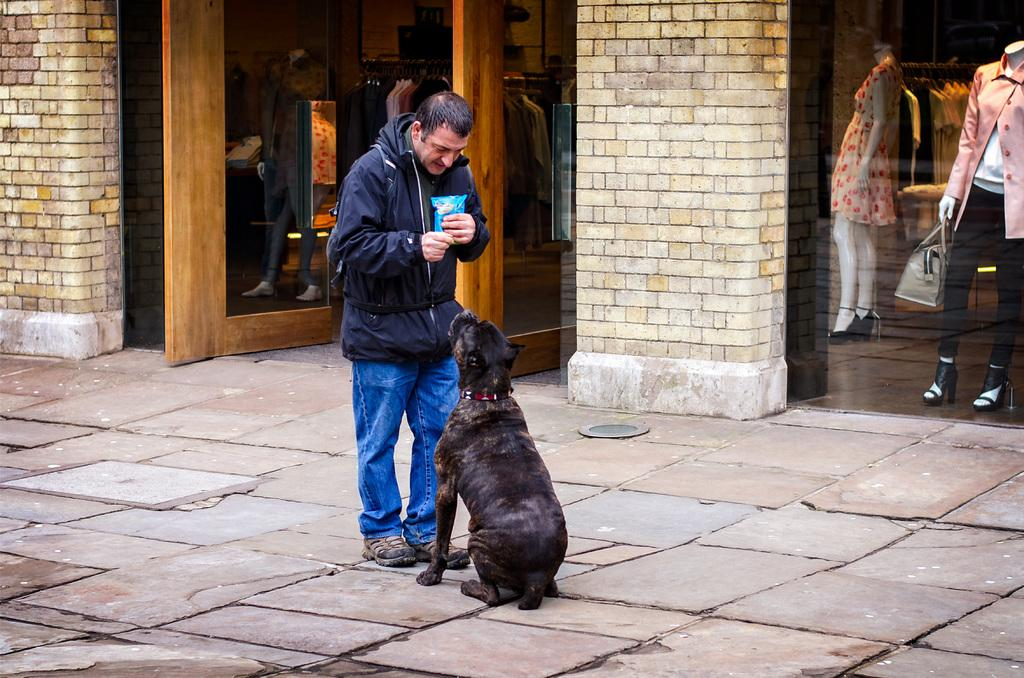Who is present in the image? There is a man in the image. What other living creature is present in the image? There is a dog in the image. Where are the man and the dog located? They are on a pavement. What can be seen in the background of the image? There is a shopping mall in the background of the image. What is a notable feature of the shopping mall? The shopping mall has glass doors. What can be seen inside the shopping mall? There are mannequins inside the shopping mall. How many icicles are hanging from the man's hat in the image? There are no icicles present in the image, as it does not depict any icy conditions. 